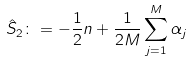Convert formula to latex. <formula><loc_0><loc_0><loc_500><loc_500>\hat { S } _ { 2 } \colon = - \frac { 1 } { 2 } n + \frac { 1 } { 2 M } \sum _ { j = 1 } ^ { M } \alpha _ { j }</formula> 